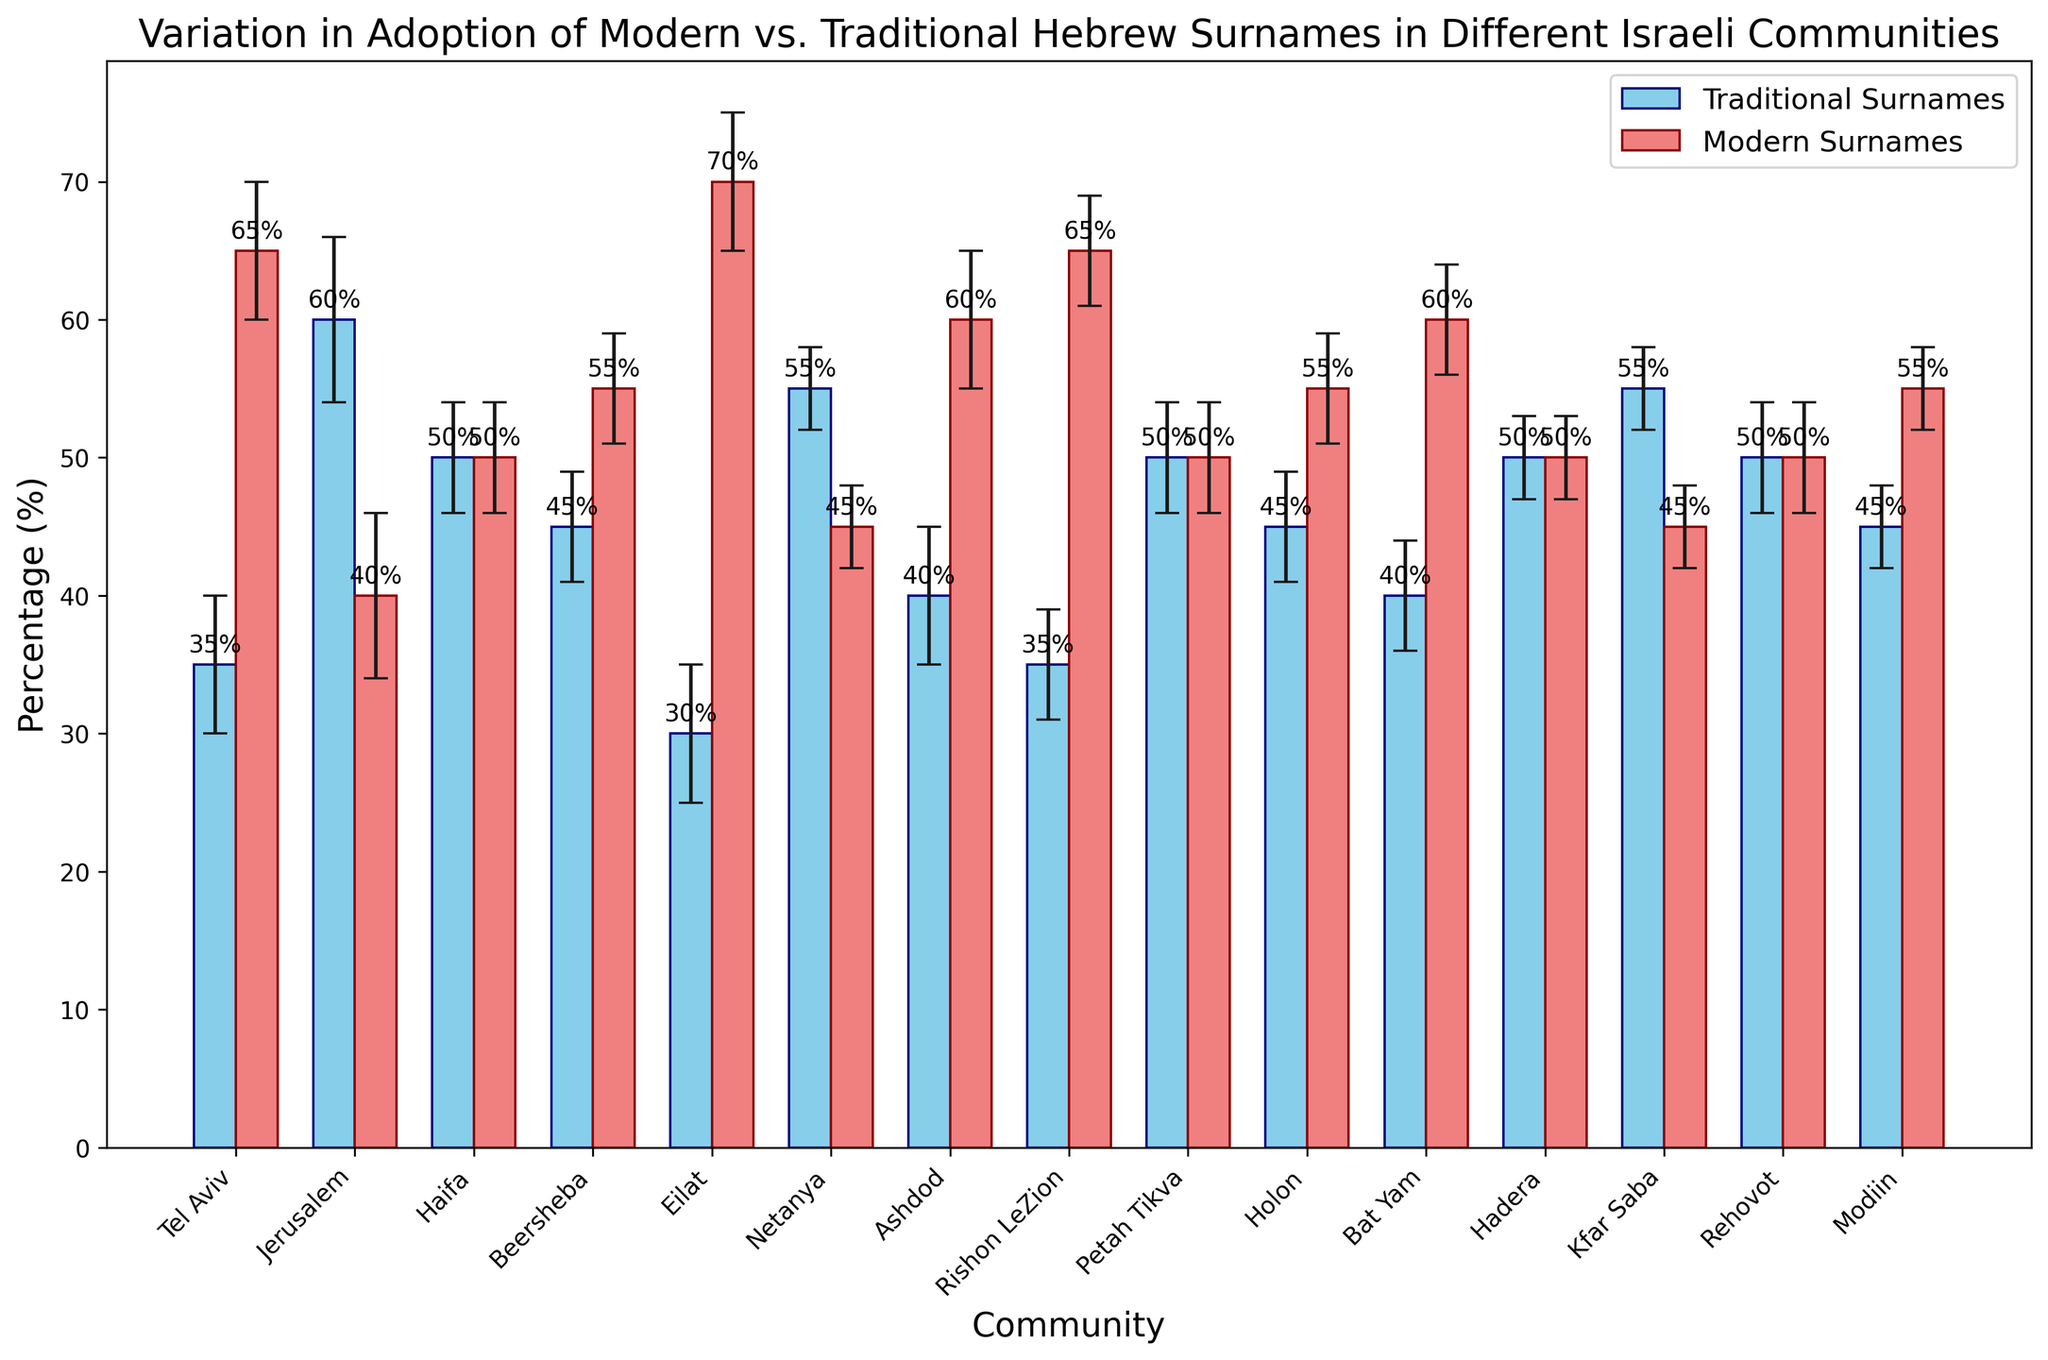What's the percentage of modern surnames in Eilat? The bar for Eilat shows that modern surnames make up 70% of the surnames.
Answer: 70% Which community has the highest percentage of traditional surnames? The bar for Jerusalem shows the highest percentage of traditional surnames at 60%.
Answer: Jerusalem What is the difference in the percentage of modern and traditional surnames in Haifa? Both modern and traditional surnames are at 50%, so the difference is 0%.
Answer: 0% Which communities have an equal percentage of modern and traditional surnames? The bars for Haifa, Petah Tikva, Hadera, and Rehovot show 50% each for modern and traditional surnames.
Answer: Haifa, Petah Tikva, Hadera, Rehovot How does the percentage of traditional surnames in Tel Aviv compare to that in Ashdod? The bar for Tel Aviv shows 35% for traditional surnames, while Ashdod shows 40%. 35% is less than 40%.
Answer: Tel Aviv is lower What's the average percentage of modern surnames in Beersheba, Holon, and Modiin? The bars for Beersheba (55%), Holon (55%), and Modiin (55%) all show 55% for modern surnames. The average is (55+55+55)/3 = 55%.
Answer: 55% Which community shows the widest margin of error for traditional surnames? The error margin for Jerusalem shows 6%, which is the highest among all communities.
Answer: Jerusalem By how much does the percentage of modern surnames in Tel Aviv exceed that of traditional surnames? The bar for Tel Aviv shows 65% for modern surnames and 35% for traditional surnames. The excess percentage is 65% - 35% = 30%.
Answer: 30% Which communities have a percentage of traditional surnames above 50%? Jerusalem (60%) and Netanya (55%) have percentages of traditional surnames above 50%.
Answer: Jerusalem, Netanya 